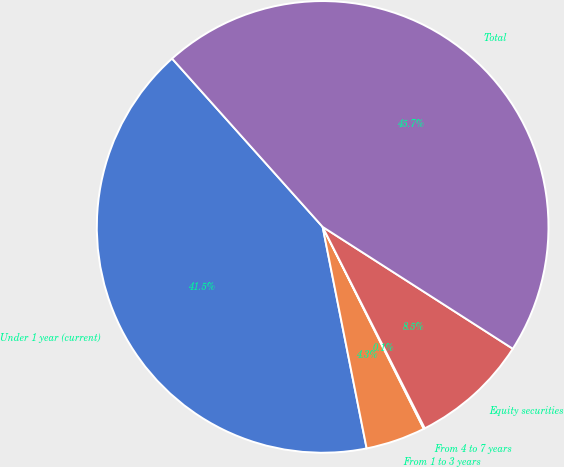Convert chart to OTSL. <chart><loc_0><loc_0><loc_500><loc_500><pie_chart><fcel>Under 1 year (current)<fcel>From 1 to 3 years<fcel>From 4 to 7 years<fcel>Equity securities<fcel>Total<nl><fcel>41.51%<fcel>4.27%<fcel>0.08%<fcel>8.46%<fcel>45.69%<nl></chart> 